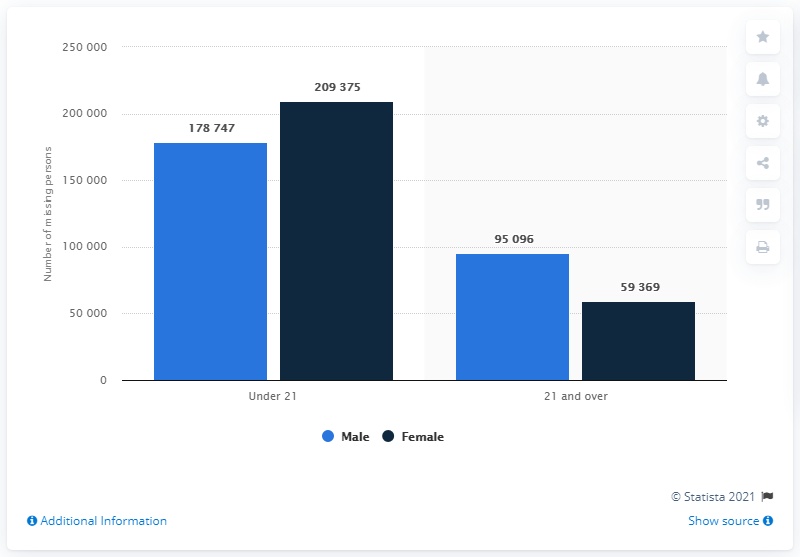Give some essential details in this illustration. The number of NCIC missing persons files was closer between the two genders in the age group under 21. The black bar value was maximum in the age group under 21. 